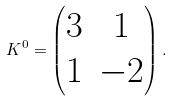Convert formula to latex. <formula><loc_0><loc_0><loc_500><loc_500>K ^ { 0 } = \left ( \begin{matrix} 3 & 1 \\ 1 & - 2 \\ \end{matrix} \right ) .</formula> 